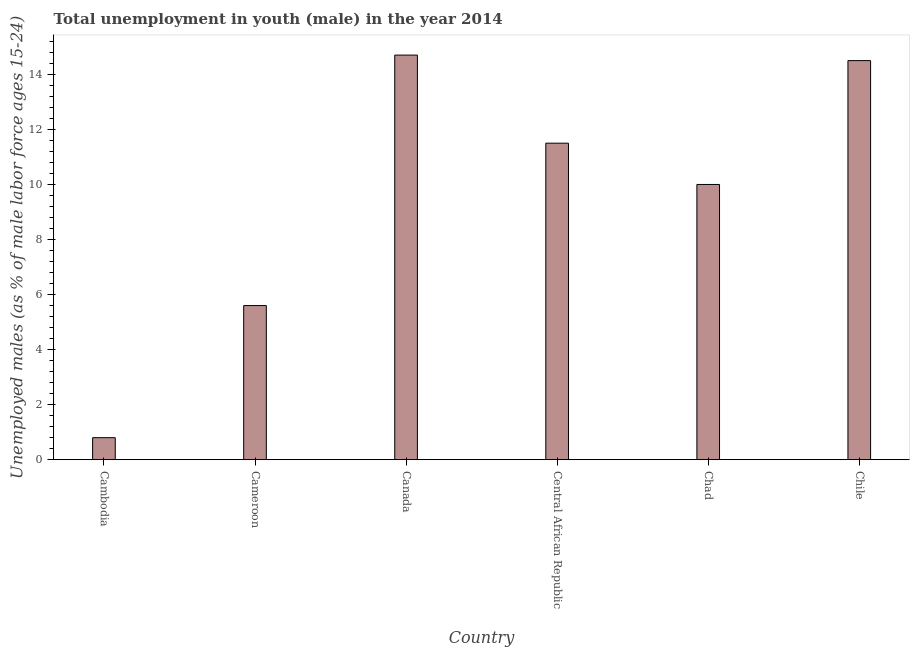What is the title of the graph?
Your answer should be very brief. Total unemployment in youth (male) in the year 2014. What is the label or title of the Y-axis?
Make the answer very short. Unemployed males (as % of male labor force ages 15-24). What is the unemployed male youth population in Chile?
Ensure brevity in your answer.  14.5. Across all countries, what is the maximum unemployed male youth population?
Your answer should be very brief. 14.7. Across all countries, what is the minimum unemployed male youth population?
Offer a very short reply. 0.8. In which country was the unemployed male youth population minimum?
Your answer should be very brief. Cambodia. What is the sum of the unemployed male youth population?
Provide a short and direct response. 57.1. What is the difference between the unemployed male youth population in Cambodia and Cameroon?
Your answer should be very brief. -4.8. What is the average unemployed male youth population per country?
Give a very brief answer. 9.52. What is the median unemployed male youth population?
Offer a terse response. 10.75. What is the ratio of the unemployed male youth population in Cameroon to that in Chile?
Offer a terse response. 0.39. Is the unemployed male youth population in Central African Republic less than that in Chad?
Give a very brief answer. No. In how many countries, is the unemployed male youth population greater than the average unemployed male youth population taken over all countries?
Your answer should be compact. 4. How many bars are there?
Keep it short and to the point. 6. What is the difference between two consecutive major ticks on the Y-axis?
Your answer should be compact. 2. Are the values on the major ticks of Y-axis written in scientific E-notation?
Make the answer very short. No. What is the Unemployed males (as % of male labor force ages 15-24) in Cambodia?
Your answer should be compact. 0.8. What is the Unemployed males (as % of male labor force ages 15-24) in Cameroon?
Provide a short and direct response. 5.6. What is the Unemployed males (as % of male labor force ages 15-24) in Canada?
Keep it short and to the point. 14.7. What is the Unemployed males (as % of male labor force ages 15-24) of Chad?
Your answer should be compact. 10. What is the difference between the Unemployed males (as % of male labor force ages 15-24) in Cambodia and Canada?
Offer a terse response. -13.9. What is the difference between the Unemployed males (as % of male labor force ages 15-24) in Cambodia and Central African Republic?
Your answer should be compact. -10.7. What is the difference between the Unemployed males (as % of male labor force ages 15-24) in Cambodia and Chile?
Your response must be concise. -13.7. What is the difference between the Unemployed males (as % of male labor force ages 15-24) in Canada and Chad?
Offer a very short reply. 4.7. What is the difference between the Unemployed males (as % of male labor force ages 15-24) in Central African Republic and Chile?
Make the answer very short. -3. What is the difference between the Unemployed males (as % of male labor force ages 15-24) in Chad and Chile?
Offer a very short reply. -4.5. What is the ratio of the Unemployed males (as % of male labor force ages 15-24) in Cambodia to that in Cameroon?
Your answer should be compact. 0.14. What is the ratio of the Unemployed males (as % of male labor force ages 15-24) in Cambodia to that in Canada?
Your answer should be compact. 0.05. What is the ratio of the Unemployed males (as % of male labor force ages 15-24) in Cambodia to that in Central African Republic?
Your response must be concise. 0.07. What is the ratio of the Unemployed males (as % of male labor force ages 15-24) in Cambodia to that in Chile?
Give a very brief answer. 0.06. What is the ratio of the Unemployed males (as % of male labor force ages 15-24) in Cameroon to that in Canada?
Your response must be concise. 0.38. What is the ratio of the Unemployed males (as % of male labor force ages 15-24) in Cameroon to that in Central African Republic?
Your response must be concise. 0.49. What is the ratio of the Unemployed males (as % of male labor force ages 15-24) in Cameroon to that in Chad?
Your answer should be compact. 0.56. What is the ratio of the Unemployed males (as % of male labor force ages 15-24) in Cameroon to that in Chile?
Your answer should be compact. 0.39. What is the ratio of the Unemployed males (as % of male labor force ages 15-24) in Canada to that in Central African Republic?
Give a very brief answer. 1.28. What is the ratio of the Unemployed males (as % of male labor force ages 15-24) in Canada to that in Chad?
Your response must be concise. 1.47. What is the ratio of the Unemployed males (as % of male labor force ages 15-24) in Canada to that in Chile?
Keep it short and to the point. 1.01. What is the ratio of the Unemployed males (as % of male labor force ages 15-24) in Central African Republic to that in Chad?
Your answer should be very brief. 1.15. What is the ratio of the Unemployed males (as % of male labor force ages 15-24) in Central African Republic to that in Chile?
Your answer should be compact. 0.79. What is the ratio of the Unemployed males (as % of male labor force ages 15-24) in Chad to that in Chile?
Your answer should be very brief. 0.69. 